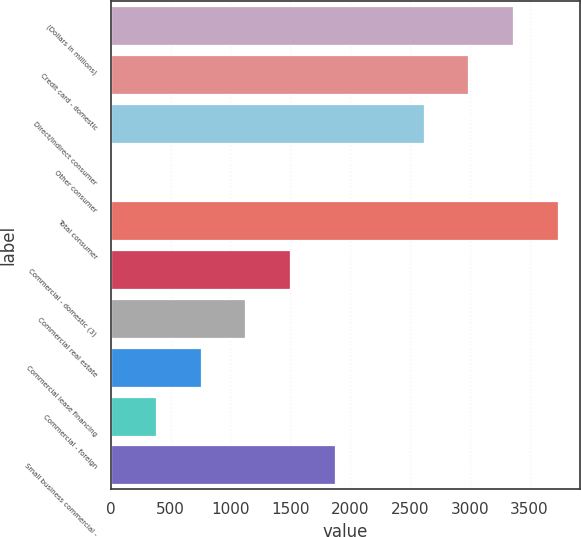Convert chart. <chart><loc_0><loc_0><loc_500><loc_500><bar_chart><fcel>(Dollars in millions)<fcel>Credit card - domestic<fcel>Direct/Indirect consumer<fcel>Other consumer<fcel>Total consumer<fcel>Commercial - domestic (3)<fcel>Commercial real estate<fcel>Commercial lease financing<fcel>Commercial - foreign<fcel>Small business commercial -<nl><fcel>3362.8<fcel>2989.6<fcel>2616.4<fcel>4<fcel>3736<fcel>1496.8<fcel>1123.6<fcel>750.4<fcel>377.2<fcel>1870<nl></chart> 